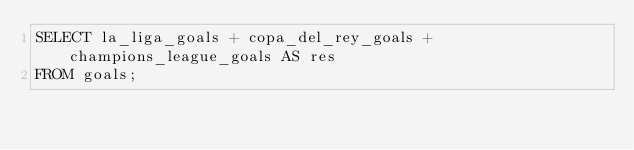<code> <loc_0><loc_0><loc_500><loc_500><_SQL_>SELECT la_liga_goals + copa_del_rey_goals + champions_league_goals AS res
FROM goals;</code> 